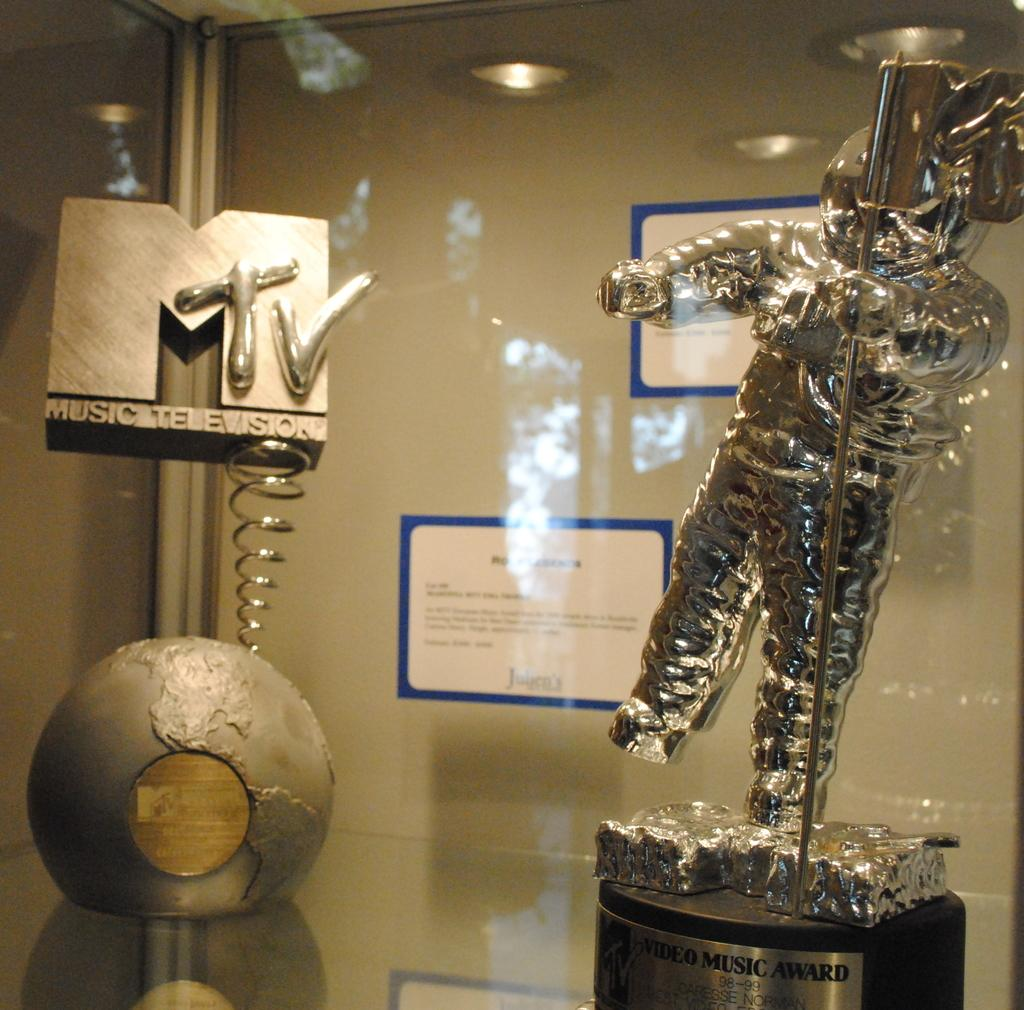What is the main subject of the image? There is a statue in the image. Where is the statue located? The statue is on a platform. What else can be seen in the image besides the statue? There are objects visible in the image. What is visible in the background of the image? There is a wall, posters, and lights in the background of the image. Can you tell me how many toads are sitting on the roof in the image? There are no toads or roofs present in the image. Are the friends of the statue visible in the image? The concept of the statue having friends is not mentioned in the image, and there are no other figures or subjects that could be considered friends of the statue. 